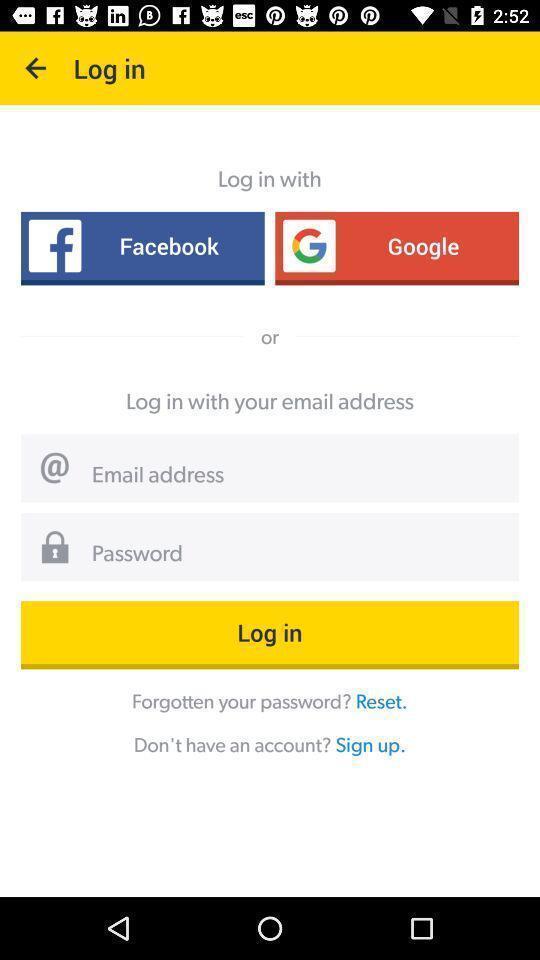Provide a detailed account of this screenshot. Login page. 